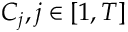<formula> <loc_0><loc_0><loc_500><loc_500>C _ { j } , j \in [ 1 , T ]</formula> 